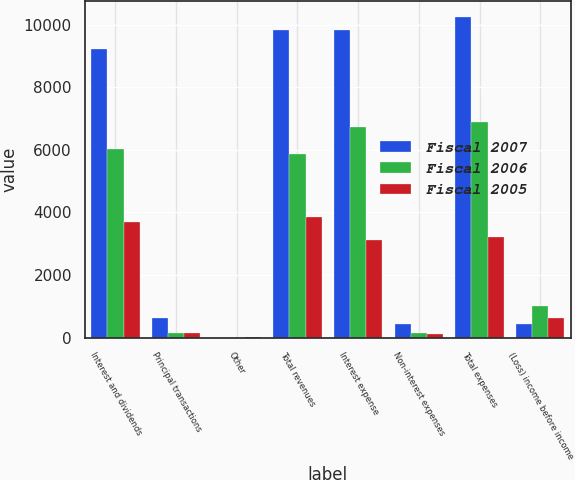<chart> <loc_0><loc_0><loc_500><loc_500><stacked_bar_chart><ecel><fcel>Interest and dividends<fcel>Principal transactions<fcel>Other<fcel>Total revenues<fcel>Interest expense<fcel>Non-interest expenses<fcel>Total expenses<fcel>(Loss) income before income<nl><fcel>Fiscal 2007<fcel>9211<fcel>613<fcel>2<fcel>9822<fcel>9834<fcel>427<fcel>10261<fcel>439<nl><fcel>Fiscal 2006<fcel>6036<fcel>156<fcel>3<fcel>5883<fcel>6744<fcel>146<fcel>6890<fcel>1007<nl><fcel>Fiscal 2005<fcel>3698<fcel>159<fcel>6<fcel>3863<fcel>3126<fcel>106<fcel>3232<fcel>631<nl></chart> 